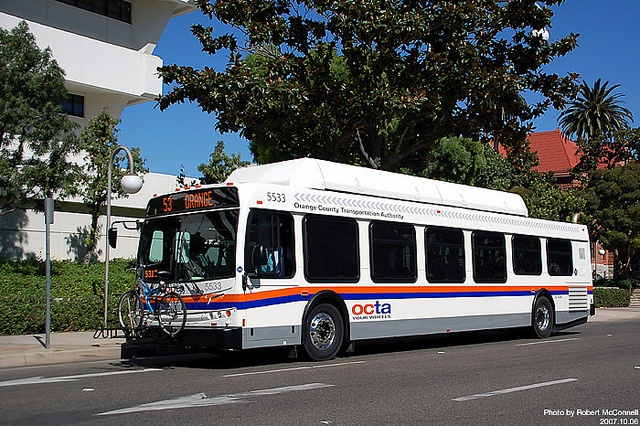Describe the objects in this image and their specific colors. I can see bus in black, white, darkgray, and gray tones and bicycle in black, gray, darkgray, and lightgray tones in this image. 